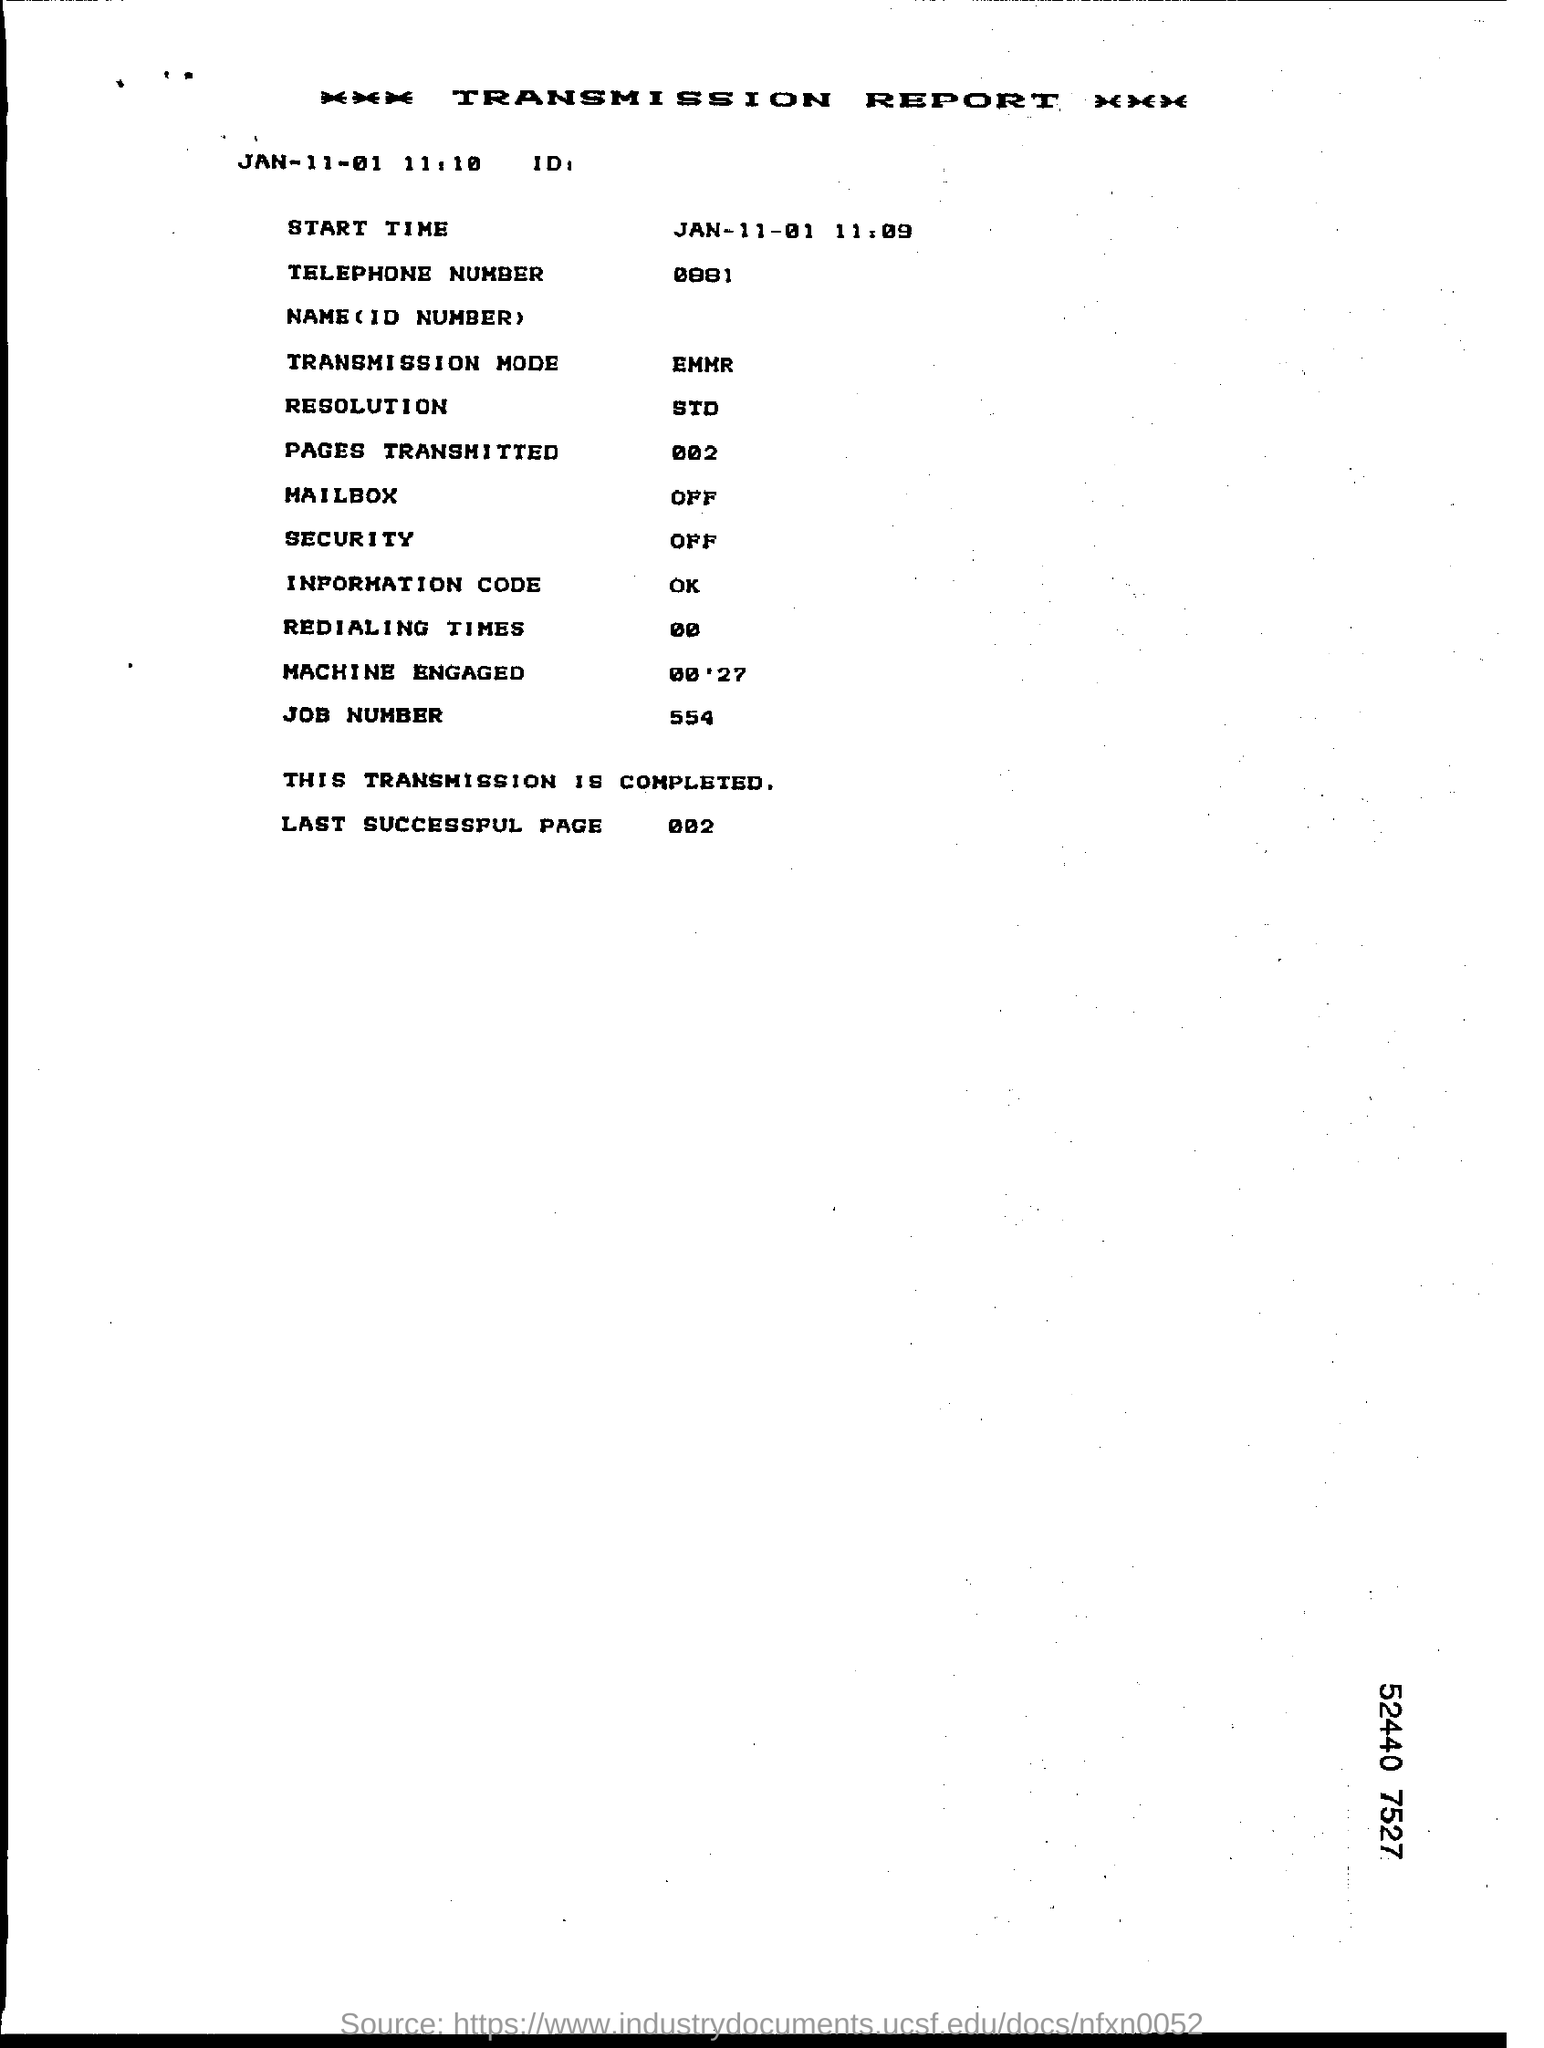Outline some significant characteristics in this image. The telephone number provided in the transmission report is 0881. The information code presented in the report is... The transmission mode is the current status in the transmission report, represented by EMMR. The last successful page in the report is number 002. The machine was engaged for 00'27" according to the transmission report. 